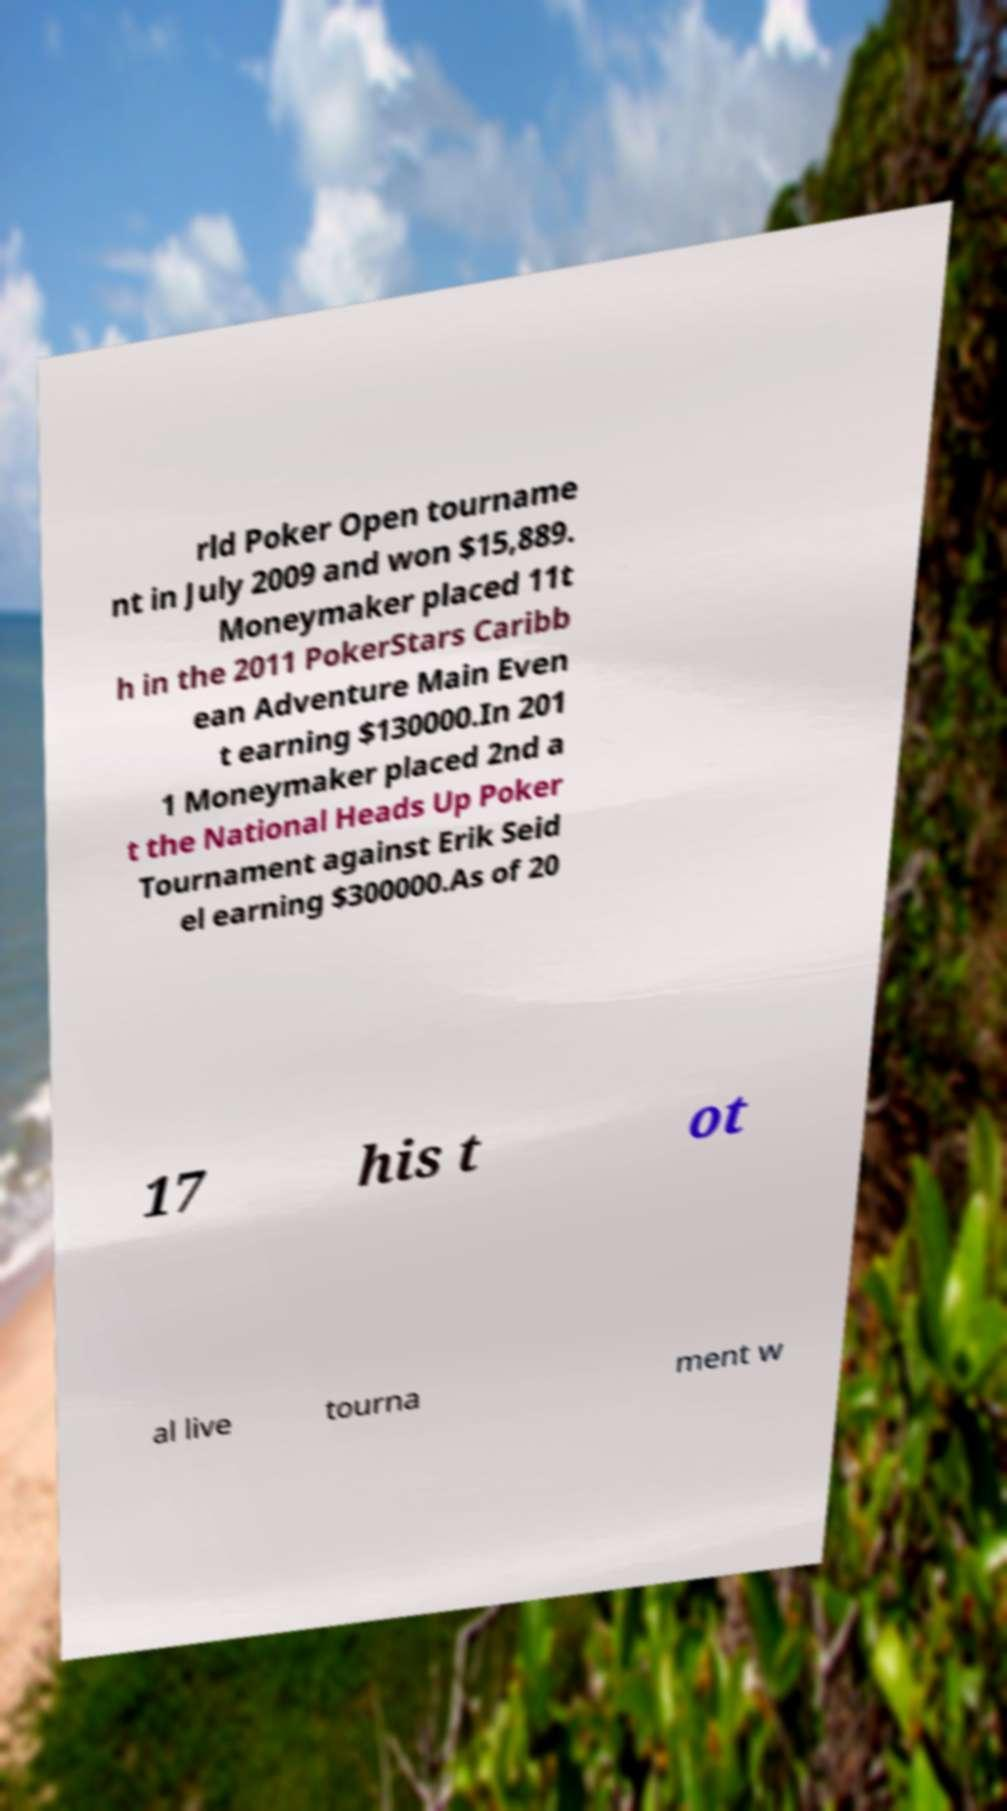I need the written content from this picture converted into text. Can you do that? rld Poker Open tourname nt in July 2009 and won $15,889. Moneymaker placed 11t h in the 2011 PokerStars Caribb ean Adventure Main Even t earning $130000.In 201 1 Moneymaker placed 2nd a t the National Heads Up Poker Tournament against Erik Seid el earning $300000.As of 20 17 his t ot al live tourna ment w 